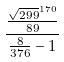Convert formula to latex. <formula><loc_0><loc_0><loc_500><loc_500>\frac { \frac { \sqrt { 2 9 9 } ^ { 1 7 0 } } { 8 9 } } { \frac { 8 } { 3 7 6 } - 1 }</formula> 